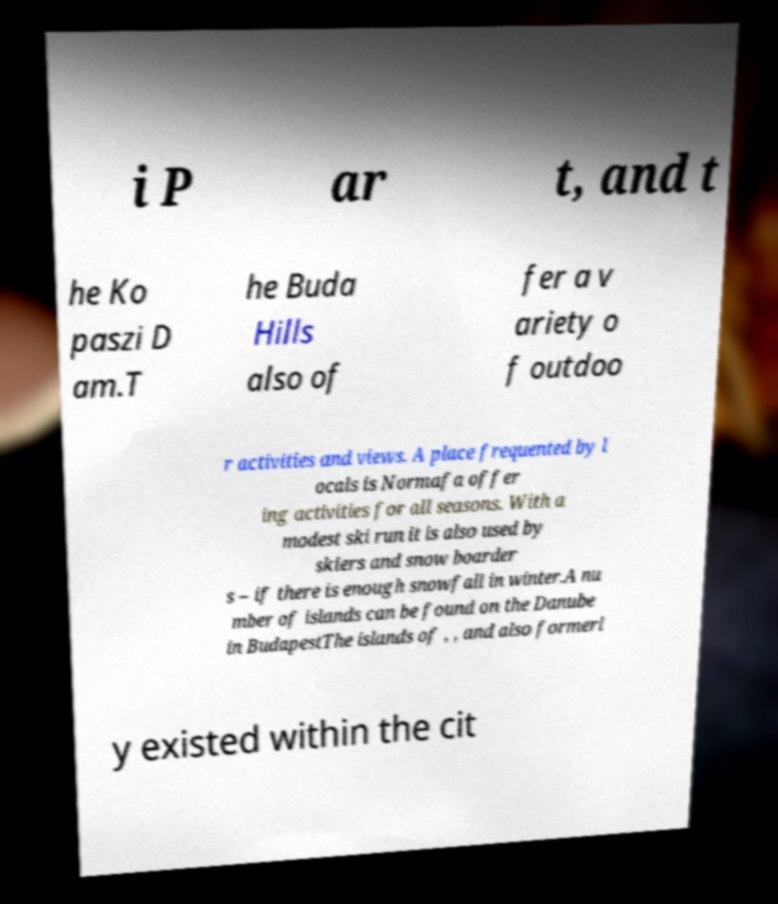Please read and relay the text visible in this image. What does it say? i P ar t, and t he Ko paszi D am.T he Buda Hills also of fer a v ariety o f outdoo r activities and views. A place frequented by l ocals is Normafa offer ing activities for all seasons. With a modest ski run it is also used by skiers and snow boarder s – if there is enough snowfall in winter.A nu mber of islands can be found on the Danube in BudapestThe islands of , , and also formerl y existed within the cit 